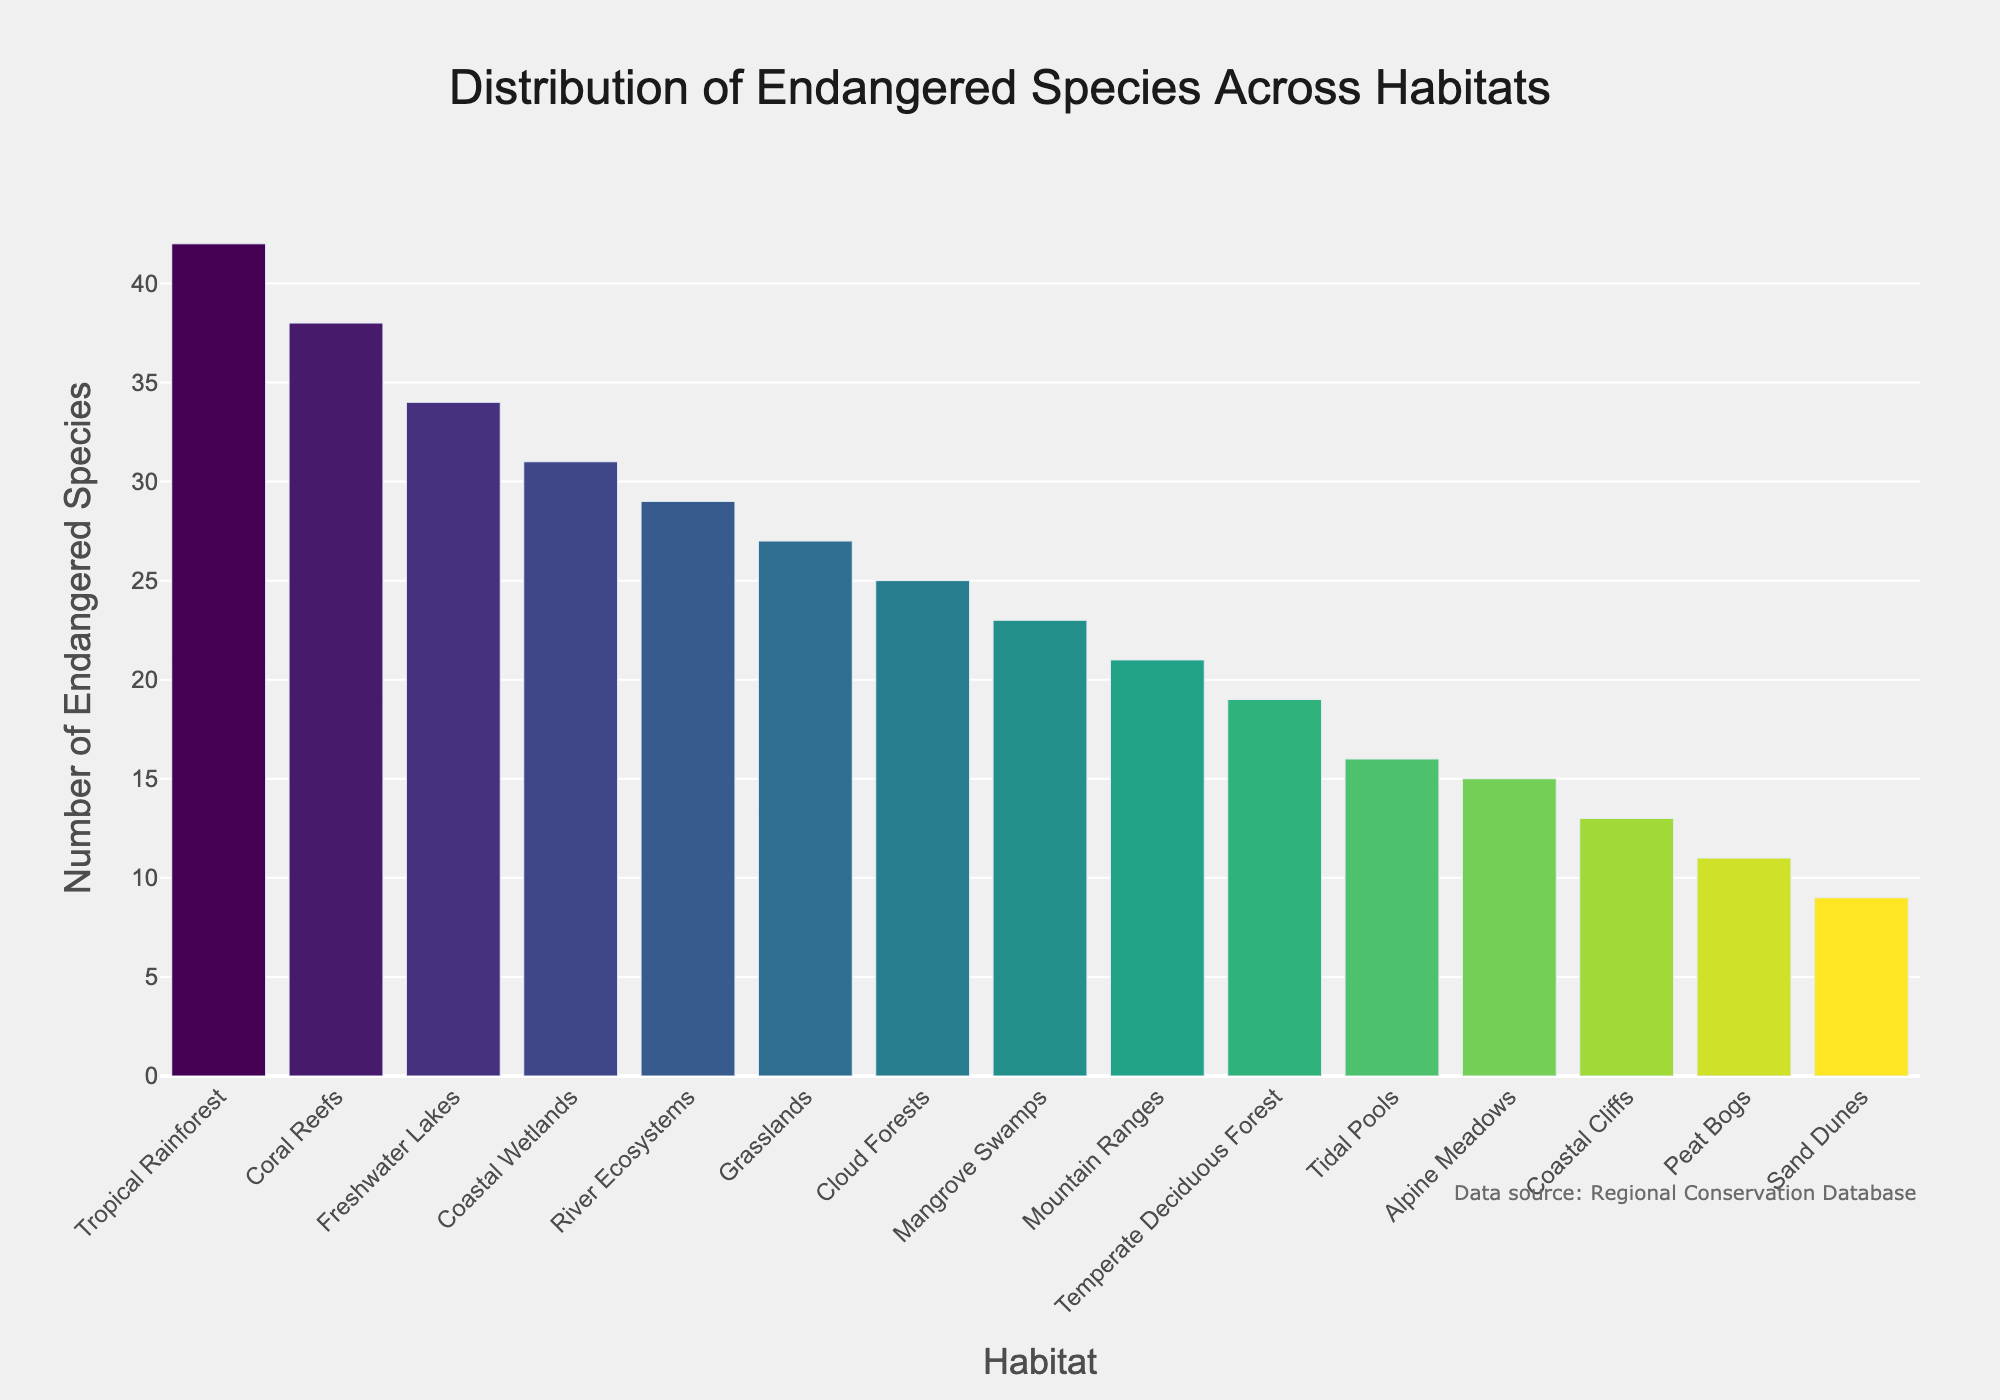Which habitat has the highest number of endangered species? From the bar chart, identify the tallest bar, which corresponds to the habitat with the highest number of endangered species. The tropical rainforest has the tallest bar.
Answer: Tropical Rainforest Which habitat has the lowest number of endangered species? From the bar chart, identify the shortest bar, which corresponds to the habitat with the lowest number of endangered species. The sand dunes have the shortest bar.
Answer: Sand Dunes How many more endangered species are there in coastal wetlands compared to temperate deciduous forests? From the chart, coastal wetlands have 31 endangered species and temperate deciduous forests have 19 endangered species. Subtract the latter from the former (31 - 19).
Answer: 12 What is the total number of endangered species in coral reefs and river ecosystems combined? From the chart, coral reefs have 38 endangered species, and river ecosystems have 29 endangered species. Sum these two numbers (38 + 29).
Answer: 67 Which two habitats have an equal number of endangered species? Identify bars with equal heights from the chart. Coastal wetlands and freshwater lakes both show 31 endangered species.
Answer: Coastal Wetlands and Freshwater Lakes What is the average number of endangered species across all habitats? Sum the number of endangered species for all habitats and divide by the number of habitats: (42 + 38 + 23 + 31 + 15 + 19 + 27 + 34 + 29 + 21 + 13 + 9 + 16 + 25 + 11) / 15. The total is 353 and there are 15 habitats.
Answer: 23.53 Which habitat ranks third in the number of endangered species? From the chart, sort the habitats in descending order by their bars' height. The habitat that appears third in this sorted list has the third highest number of endangered species. Freshwater lakes rank third.
Answer: Freshwater Lakes Are there more endangered species in mangrove swamps or in alpine meadows? Compare the heights of the bars corresponding to mangrove swamps and alpine meadows. Mangrove swamps have 23 species, and alpine meadows have 15.
Answer: Mangrove Swamps What is the difference in the number of endangered species between the habitat with the highest and the lowest number of endangered species? The tropical rainforest has 42 endangered species (the highest), and sand dunes have 9 (the lowest). Subtract the latter from the former (42 - 9).
Answer: 33 Among coastal wetlands, tidal pools, and peat bogs, which habitat has the middle number of endangered species? From the chart, coastal wetlands have 31 endangered species, tidal pools have 16, and peat bogs have 11. The middle value between 31, 16, and 11 is 16.
Answer: Tidal Pools 